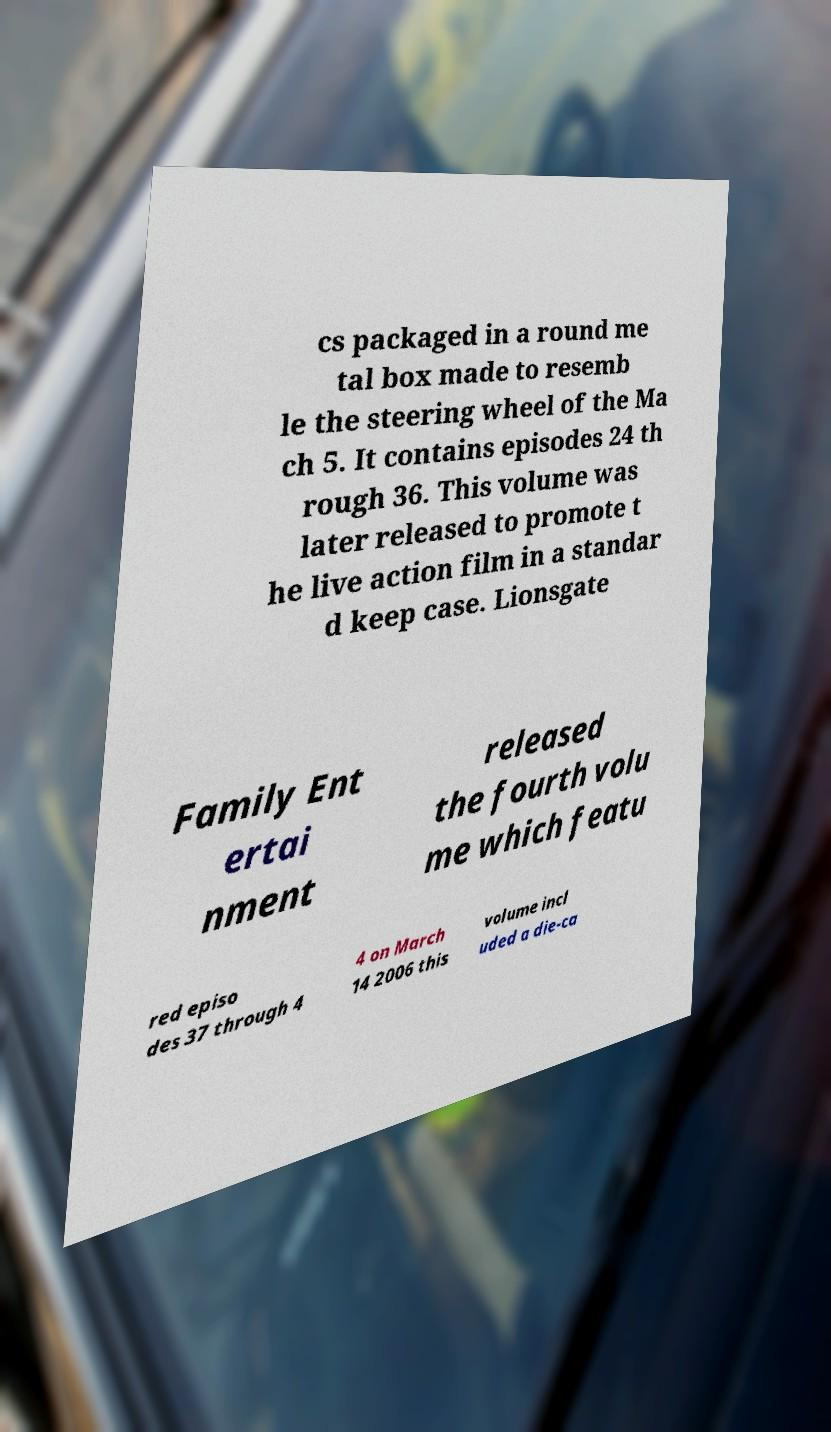For documentation purposes, I need the text within this image transcribed. Could you provide that? cs packaged in a round me tal box made to resemb le the steering wheel of the Ma ch 5. It contains episodes 24 th rough 36. This volume was later released to promote t he live action film in a standar d keep case. Lionsgate Family Ent ertai nment released the fourth volu me which featu red episo des 37 through 4 4 on March 14 2006 this volume incl uded a die-ca 